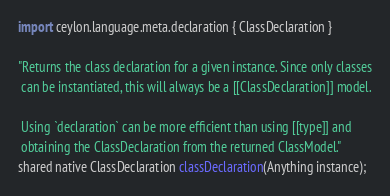Convert code to text. <code><loc_0><loc_0><loc_500><loc_500><_Ceylon_>import ceylon.language.meta.declaration { ClassDeclaration }

"Returns the class declaration for a given instance. Since only classes
 can be instantiated, this will always be a [[ClassDeclaration]] model.
 
 Using `declaration` can be more efficient than using [[type]] and 
 obtaining the ClassDeclaration from the returned ClassModel."
shared native ClassDeclaration classDeclaration(Anything instance);</code> 